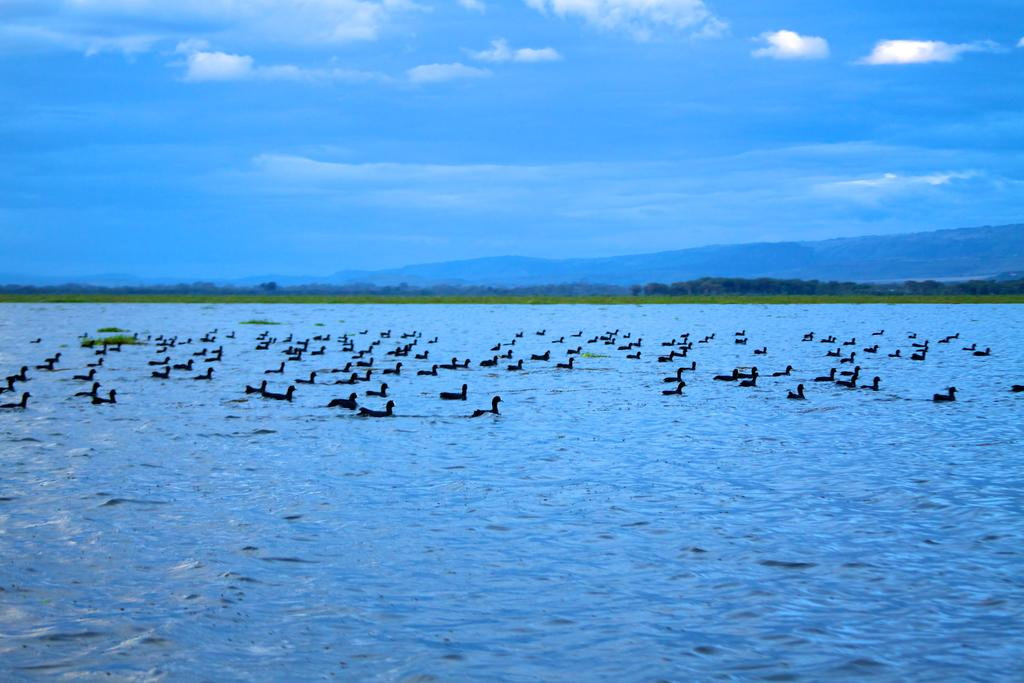What animals can be seen in the image? There are birds on the surface of the water in the image. What type of vegetation is present in the image? There is greenery in the middle of the image. What is visible in the sky in the image? The sky with clouds is visible at the top of the image. What type of experience can be felt by touching the moon in the image? There is no moon present in the image, so it is not possible to experience touching it. 